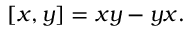Convert formula to latex. <formula><loc_0><loc_0><loc_500><loc_500>[ x , y ] = x y - y x .</formula> 